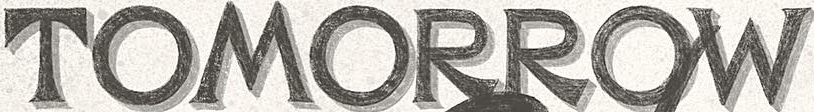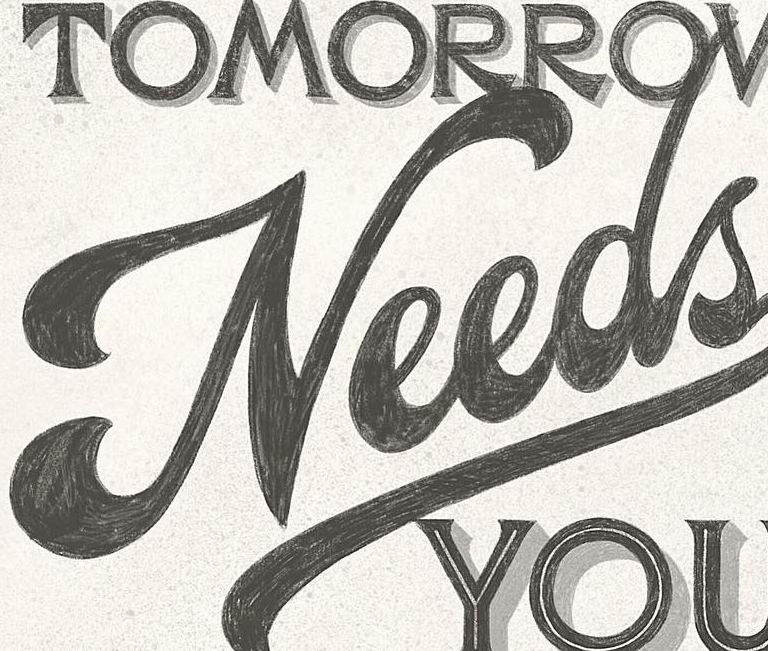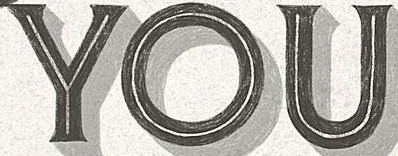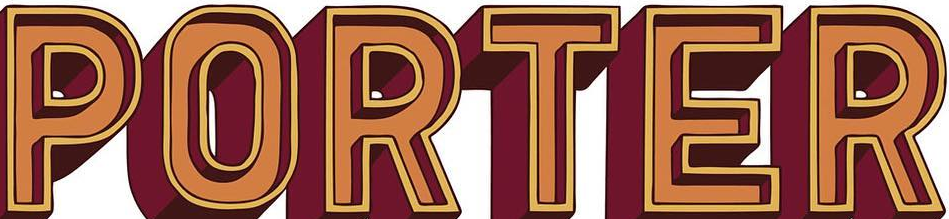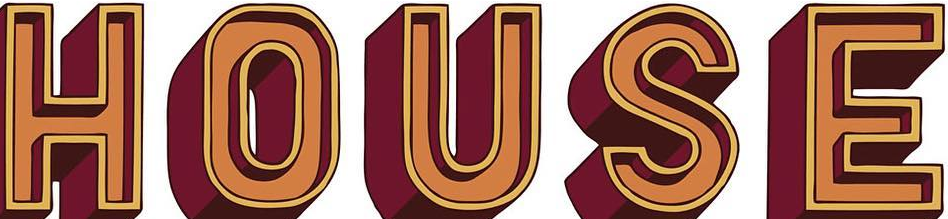Identify the words shown in these images in order, separated by a semicolon. TOMORROW; Needs; YOU; PORTER; HOUSE 